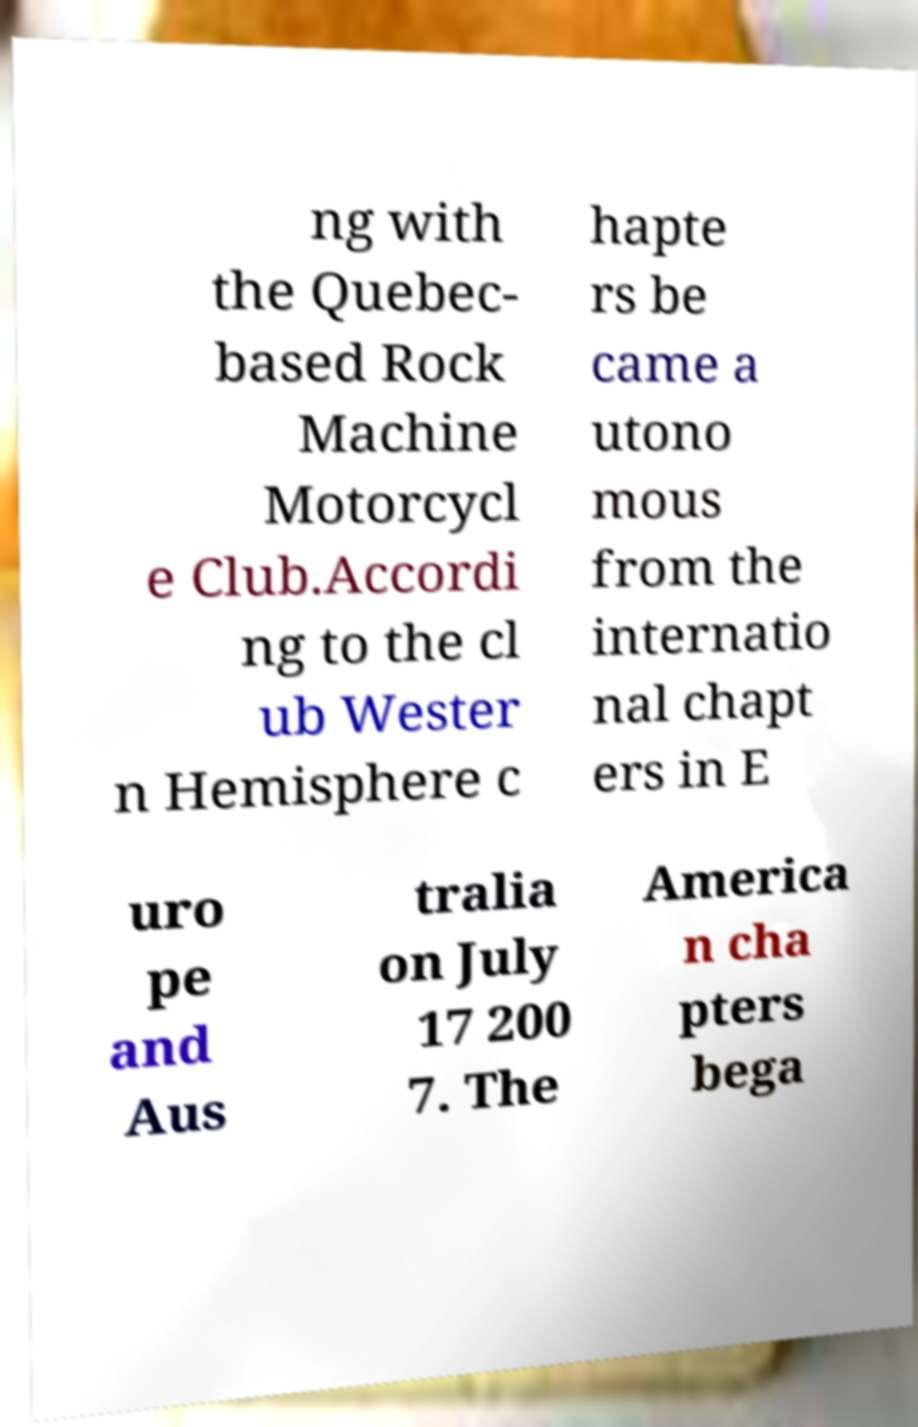Can you accurately transcribe the text from the provided image for me? ng with the Quebec- based Rock Machine Motorcycl e Club.Accordi ng to the cl ub Wester n Hemisphere c hapte rs be came a utono mous from the internatio nal chapt ers in E uro pe and Aus tralia on July 17 200 7. The America n cha pters bega 